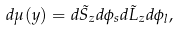<formula> <loc_0><loc_0><loc_500><loc_500>d \mu ( { y } ) = d \tilde { S } _ { z } d \phi _ { s } d \tilde { L } _ { z } d \phi _ { l } ,</formula> 